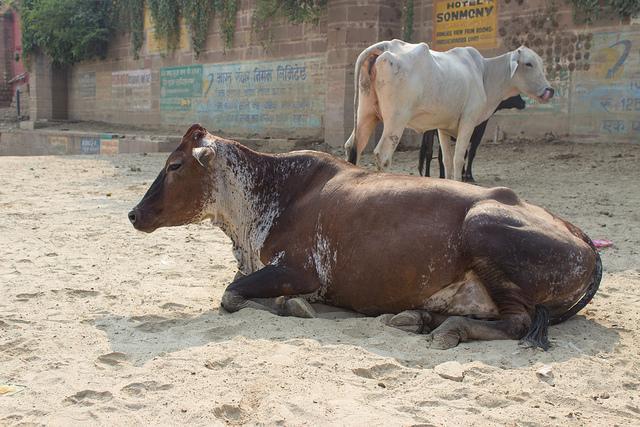How many cows are there?
Give a very brief answer. 2. How many cows can be seen?
Give a very brief answer. 2. 